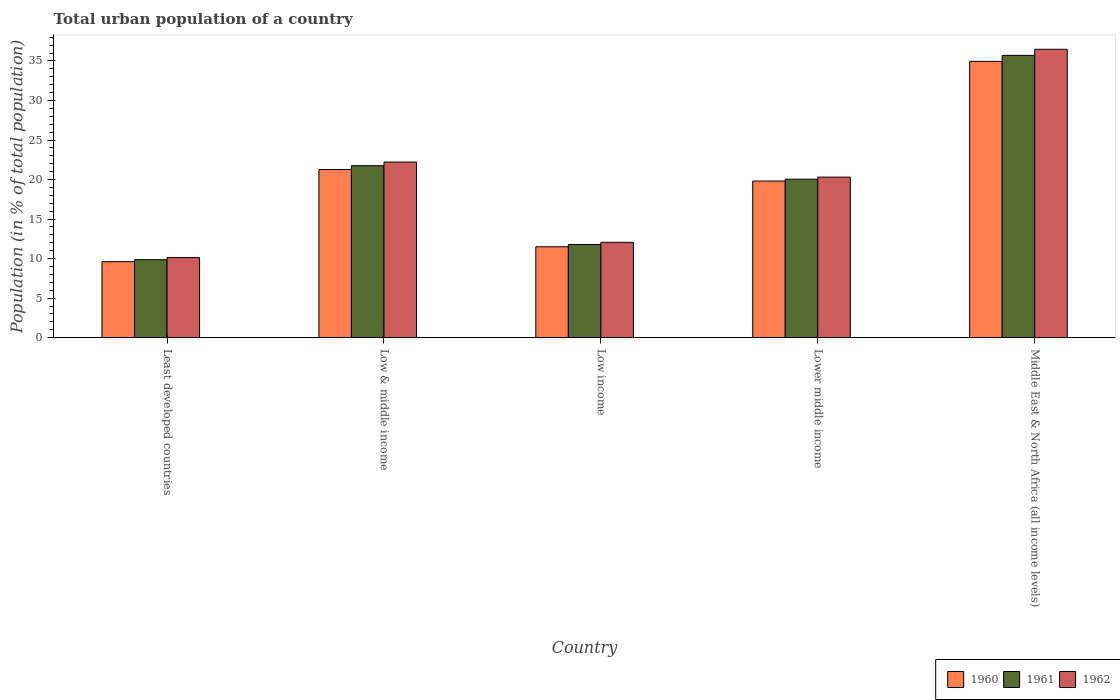What is the label of the 4th group of bars from the left?
Offer a terse response. Lower middle income. In how many cases, is the number of bars for a given country not equal to the number of legend labels?
Your answer should be very brief. 0. What is the urban population in 1962 in Middle East & North Africa (all income levels)?
Offer a very short reply. 36.48. Across all countries, what is the maximum urban population in 1961?
Provide a short and direct response. 35.71. Across all countries, what is the minimum urban population in 1962?
Provide a succinct answer. 10.13. In which country was the urban population in 1961 maximum?
Provide a short and direct response. Middle East & North Africa (all income levels). In which country was the urban population in 1961 minimum?
Offer a terse response. Least developed countries. What is the total urban population in 1962 in the graph?
Your answer should be very brief. 101.19. What is the difference between the urban population in 1962 in Low income and that in Lower middle income?
Your answer should be very brief. -8.25. What is the difference between the urban population in 1961 in Low income and the urban population in 1962 in Least developed countries?
Ensure brevity in your answer.  1.65. What is the average urban population in 1960 per country?
Your answer should be very brief. 19.43. What is the difference between the urban population of/in 1960 and urban population of/in 1961 in Middle East & North Africa (all income levels)?
Offer a very short reply. -0.76. In how many countries, is the urban population in 1961 greater than 5 %?
Keep it short and to the point. 5. What is the ratio of the urban population in 1961 in Low & middle income to that in Middle East & North Africa (all income levels)?
Provide a succinct answer. 0.61. Is the urban population in 1961 in Low & middle income less than that in Middle East & North Africa (all income levels)?
Your response must be concise. Yes. Is the difference between the urban population in 1960 in Low & middle income and Low income greater than the difference between the urban population in 1961 in Low & middle income and Low income?
Make the answer very short. No. What is the difference between the highest and the second highest urban population in 1960?
Your response must be concise. 15.14. What is the difference between the highest and the lowest urban population in 1962?
Ensure brevity in your answer.  26.35. In how many countries, is the urban population in 1961 greater than the average urban population in 1961 taken over all countries?
Provide a short and direct response. 3. Is the sum of the urban population in 1960 in Low income and Middle East & North Africa (all income levels) greater than the maximum urban population in 1962 across all countries?
Keep it short and to the point. Yes. What does the 1st bar from the left in Low & middle income represents?
Provide a succinct answer. 1960. How many countries are there in the graph?
Your response must be concise. 5. Does the graph contain grids?
Keep it short and to the point. No. Where does the legend appear in the graph?
Make the answer very short. Bottom right. How many legend labels are there?
Offer a very short reply. 3. What is the title of the graph?
Offer a terse response. Total urban population of a country. Does "2003" appear as one of the legend labels in the graph?
Offer a terse response. No. What is the label or title of the X-axis?
Offer a terse response. Country. What is the label or title of the Y-axis?
Offer a terse response. Population (in % of total population). What is the Population (in % of total population) of 1960 in Least developed countries?
Provide a succinct answer. 9.62. What is the Population (in % of total population) of 1961 in Least developed countries?
Give a very brief answer. 9.86. What is the Population (in % of total population) of 1962 in Least developed countries?
Your answer should be compact. 10.13. What is the Population (in % of total population) of 1960 in Low & middle income?
Offer a terse response. 21.27. What is the Population (in % of total population) of 1961 in Low & middle income?
Provide a succinct answer. 21.75. What is the Population (in % of total population) of 1962 in Low & middle income?
Keep it short and to the point. 22.22. What is the Population (in % of total population) in 1960 in Low income?
Provide a succinct answer. 11.5. What is the Population (in % of total population) in 1961 in Low income?
Your answer should be compact. 11.78. What is the Population (in % of total population) of 1962 in Low income?
Offer a very short reply. 12.06. What is the Population (in % of total population) of 1960 in Lower middle income?
Your response must be concise. 19.81. What is the Population (in % of total population) in 1961 in Lower middle income?
Give a very brief answer. 20.04. What is the Population (in % of total population) of 1962 in Lower middle income?
Offer a terse response. 20.31. What is the Population (in % of total population) in 1960 in Middle East & North Africa (all income levels)?
Make the answer very short. 34.95. What is the Population (in % of total population) of 1961 in Middle East & North Africa (all income levels)?
Your answer should be very brief. 35.71. What is the Population (in % of total population) of 1962 in Middle East & North Africa (all income levels)?
Offer a very short reply. 36.48. Across all countries, what is the maximum Population (in % of total population) of 1960?
Give a very brief answer. 34.95. Across all countries, what is the maximum Population (in % of total population) in 1961?
Provide a short and direct response. 35.71. Across all countries, what is the maximum Population (in % of total population) of 1962?
Provide a short and direct response. 36.48. Across all countries, what is the minimum Population (in % of total population) in 1960?
Provide a succinct answer. 9.62. Across all countries, what is the minimum Population (in % of total population) of 1961?
Your response must be concise. 9.86. Across all countries, what is the minimum Population (in % of total population) of 1962?
Give a very brief answer. 10.13. What is the total Population (in % of total population) of 1960 in the graph?
Keep it short and to the point. 97.15. What is the total Population (in % of total population) in 1961 in the graph?
Offer a terse response. 99.14. What is the total Population (in % of total population) of 1962 in the graph?
Provide a succinct answer. 101.19. What is the difference between the Population (in % of total population) of 1960 in Least developed countries and that in Low & middle income?
Offer a very short reply. -11.66. What is the difference between the Population (in % of total population) in 1961 in Least developed countries and that in Low & middle income?
Provide a succinct answer. -11.89. What is the difference between the Population (in % of total population) of 1962 in Least developed countries and that in Low & middle income?
Keep it short and to the point. -12.09. What is the difference between the Population (in % of total population) in 1960 in Least developed countries and that in Low income?
Offer a terse response. -1.88. What is the difference between the Population (in % of total population) of 1961 in Least developed countries and that in Low income?
Keep it short and to the point. -1.92. What is the difference between the Population (in % of total population) in 1962 in Least developed countries and that in Low income?
Provide a succinct answer. -1.93. What is the difference between the Population (in % of total population) of 1960 in Least developed countries and that in Lower middle income?
Offer a very short reply. -10.19. What is the difference between the Population (in % of total population) of 1961 in Least developed countries and that in Lower middle income?
Your answer should be compact. -10.18. What is the difference between the Population (in % of total population) in 1962 in Least developed countries and that in Lower middle income?
Offer a terse response. -10.18. What is the difference between the Population (in % of total population) of 1960 in Least developed countries and that in Middle East & North Africa (all income levels)?
Provide a succinct answer. -25.34. What is the difference between the Population (in % of total population) of 1961 in Least developed countries and that in Middle East & North Africa (all income levels)?
Keep it short and to the point. -25.85. What is the difference between the Population (in % of total population) in 1962 in Least developed countries and that in Middle East & North Africa (all income levels)?
Give a very brief answer. -26.35. What is the difference between the Population (in % of total population) in 1960 in Low & middle income and that in Low income?
Your answer should be very brief. 9.77. What is the difference between the Population (in % of total population) of 1961 in Low & middle income and that in Low income?
Your answer should be compact. 9.97. What is the difference between the Population (in % of total population) in 1962 in Low & middle income and that in Low income?
Your response must be concise. 10.16. What is the difference between the Population (in % of total population) of 1960 in Low & middle income and that in Lower middle income?
Offer a very short reply. 1.46. What is the difference between the Population (in % of total population) in 1961 in Low & middle income and that in Lower middle income?
Offer a terse response. 1.71. What is the difference between the Population (in % of total population) of 1962 in Low & middle income and that in Lower middle income?
Keep it short and to the point. 1.91. What is the difference between the Population (in % of total population) in 1960 in Low & middle income and that in Middle East & North Africa (all income levels)?
Offer a terse response. -13.68. What is the difference between the Population (in % of total population) in 1961 in Low & middle income and that in Middle East & North Africa (all income levels)?
Your response must be concise. -13.96. What is the difference between the Population (in % of total population) in 1962 in Low & middle income and that in Middle East & North Africa (all income levels)?
Your response must be concise. -14.26. What is the difference between the Population (in % of total population) in 1960 in Low income and that in Lower middle income?
Make the answer very short. -8.31. What is the difference between the Population (in % of total population) of 1961 in Low income and that in Lower middle income?
Give a very brief answer. -8.26. What is the difference between the Population (in % of total population) of 1962 in Low income and that in Lower middle income?
Keep it short and to the point. -8.25. What is the difference between the Population (in % of total population) of 1960 in Low income and that in Middle East & North Africa (all income levels)?
Ensure brevity in your answer.  -23.45. What is the difference between the Population (in % of total population) of 1961 in Low income and that in Middle East & North Africa (all income levels)?
Provide a succinct answer. -23.93. What is the difference between the Population (in % of total population) of 1962 in Low income and that in Middle East & North Africa (all income levels)?
Provide a short and direct response. -24.42. What is the difference between the Population (in % of total population) in 1960 in Lower middle income and that in Middle East & North Africa (all income levels)?
Your answer should be compact. -15.14. What is the difference between the Population (in % of total population) in 1961 in Lower middle income and that in Middle East & North Africa (all income levels)?
Ensure brevity in your answer.  -15.67. What is the difference between the Population (in % of total population) in 1962 in Lower middle income and that in Middle East & North Africa (all income levels)?
Offer a very short reply. -16.17. What is the difference between the Population (in % of total population) in 1960 in Least developed countries and the Population (in % of total population) in 1961 in Low & middle income?
Your answer should be compact. -12.13. What is the difference between the Population (in % of total population) of 1960 in Least developed countries and the Population (in % of total population) of 1962 in Low & middle income?
Provide a succinct answer. -12.6. What is the difference between the Population (in % of total population) in 1961 in Least developed countries and the Population (in % of total population) in 1962 in Low & middle income?
Your answer should be compact. -12.36. What is the difference between the Population (in % of total population) of 1960 in Least developed countries and the Population (in % of total population) of 1961 in Low income?
Your answer should be very brief. -2.16. What is the difference between the Population (in % of total population) of 1960 in Least developed countries and the Population (in % of total population) of 1962 in Low income?
Your answer should be very brief. -2.44. What is the difference between the Population (in % of total population) in 1961 in Least developed countries and the Population (in % of total population) in 1962 in Low income?
Keep it short and to the point. -2.2. What is the difference between the Population (in % of total population) of 1960 in Least developed countries and the Population (in % of total population) of 1961 in Lower middle income?
Give a very brief answer. -10.43. What is the difference between the Population (in % of total population) in 1960 in Least developed countries and the Population (in % of total population) in 1962 in Lower middle income?
Give a very brief answer. -10.69. What is the difference between the Population (in % of total population) of 1961 in Least developed countries and the Population (in % of total population) of 1962 in Lower middle income?
Provide a short and direct response. -10.45. What is the difference between the Population (in % of total population) of 1960 in Least developed countries and the Population (in % of total population) of 1961 in Middle East & North Africa (all income levels)?
Keep it short and to the point. -26.09. What is the difference between the Population (in % of total population) in 1960 in Least developed countries and the Population (in % of total population) in 1962 in Middle East & North Africa (all income levels)?
Provide a succinct answer. -26.86. What is the difference between the Population (in % of total population) in 1961 in Least developed countries and the Population (in % of total population) in 1962 in Middle East & North Africa (all income levels)?
Your response must be concise. -26.61. What is the difference between the Population (in % of total population) in 1960 in Low & middle income and the Population (in % of total population) in 1961 in Low income?
Offer a very short reply. 9.49. What is the difference between the Population (in % of total population) in 1960 in Low & middle income and the Population (in % of total population) in 1962 in Low income?
Your answer should be very brief. 9.21. What is the difference between the Population (in % of total population) in 1961 in Low & middle income and the Population (in % of total population) in 1962 in Low income?
Your answer should be compact. 9.69. What is the difference between the Population (in % of total population) in 1960 in Low & middle income and the Population (in % of total population) in 1961 in Lower middle income?
Offer a terse response. 1.23. What is the difference between the Population (in % of total population) of 1960 in Low & middle income and the Population (in % of total population) of 1962 in Lower middle income?
Keep it short and to the point. 0.96. What is the difference between the Population (in % of total population) in 1961 in Low & middle income and the Population (in % of total population) in 1962 in Lower middle income?
Your answer should be very brief. 1.44. What is the difference between the Population (in % of total population) in 1960 in Low & middle income and the Population (in % of total population) in 1961 in Middle East & North Africa (all income levels)?
Provide a short and direct response. -14.44. What is the difference between the Population (in % of total population) of 1960 in Low & middle income and the Population (in % of total population) of 1962 in Middle East & North Africa (all income levels)?
Your answer should be compact. -15.2. What is the difference between the Population (in % of total population) in 1961 in Low & middle income and the Population (in % of total population) in 1962 in Middle East & North Africa (all income levels)?
Ensure brevity in your answer.  -14.73. What is the difference between the Population (in % of total population) in 1960 in Low income and the Population (in % of total population) in 1961 in Lower middle income?
Your answer should be very brief. -8.54. What is the difference between the Population (in % of total population) of 1960 in Low income and the Population (in % of total population) of 1962 in Lower middle income?
Provide a succinct answer. -8.81. What is the difference between the Population (in % of total population) in 1961 in Low income and the Population (in % of total population) in 1962 in Lower middle income?
Keep it short and to the point. -8.53. What is the difference between the Population (in % of total population) in 1960 in Low income and the Population (in % of total population) in 1961 in Middle East & North Africa (all income levels)?
Keep it short and to the point. -24.21. What is the difference between the Population (in % of total population) in 1960 in Low income and the Population (in % of total population) in 1962 in Middle East & North Africa (all income levels)?
Your response must be concise. -24.98. What is the difference between the Population (in % of total population) of 1961 in Low income and the Population (in % of total population) of 1962 in Middle East & North Africa (all income levels)?
Give a very brief answer. -24.7. What is the difference between the Population (in % of total population) in 1960 in Lower middle income and the Population (in % of total population) in 1961 in Middle East & North Africa (all income levels)?
Your response must be concise. -15.9. What is the difference between the Population (in % of total population) of 1960 in Lower middle income and the Population (in % of total population) of 1962 in Middle East & North Africa (all income levels)?
Provide a short and direct response. -16.67. What is the difference between the Population (in % of total population) in 1961 in Lower middle income and the Population (in % of total population) in 1962 in Middle East & North Africa (all income levels)?
Make the answer very short. -16.43. What is the average Population (in % of total population) in 1960 per country?
Provide a succinct answer. 19.43. What is the average Population (in % of total population) of 1961 per country?
Ensure brevity in your answer.  19.83. What is the average Population (in % of total population) of 1962 per country?
Your answer should be very brief. 20.24. What is the difference between the Population (in % of total population) of 1960 and Population (in % of total population) of 1961 in Least developed countries?
Make the answer very short. -0.25. What is the difference between the Population (in % of total population) of 1960 and Population (in % of total population) of 1962 in Least developed countries?
Give a very brief answer. -0.51. What is the difference between the Population (in % of total population) in 1961 and Population (in % of total population) in 1962 in Least developed countries?
Your response must be concise. -0.27. What is the difference between the Population (in % of total population) in 1960 and Population (in % of total population) in 1961 in Low & middle income?
Offer a very short reply. -0.48. What is the difference between the Population (in % of total population) of 1960 and Population (in % of total population) of 1962 in Low & middle income?
Give a very brief answer. -0.95. What is the difference between the Population (in % of total population) in 1961 and Population (in % of total population) in 1962 in Low & middle income?
Your response must be concise. -0.47. What is the difference between the Population (in % of total population) of 1960 and Population (in % of total population) of 1961 in Low income?
Your answer should be very brief. -0.28. What is the difference between the Population (in % of total population) in 1960 and Population (in % of total population) in 1962 in Low income?
Provide a short and direct response. -0.56. What is the difference between the Population (in % of total population) of 1961 and Population (in % of total population) of 1962 in Low income?
Provide a short and direct response. -0.28. What is the difference between the Population (in % of total population) in 1960 and Population (in % of total population) in 1961 in Lower middle income?
Offer a very short reply. -0.23. What is the difference between the Population (in % of total population) in 1960 and Population (in % of total population) in 1962 in Lower middle income?
Your answer should be very brief. -0.5. What is the difference between the Population (in % of total population) in 1961 and Population (in % of total population) in 1962 in Lower middle income?
Make the answer very short. -0.27. What is the difference between the Population (in % of total population) of 1960 and Population (in % of total population) of 1961 in Middle East & North Africa (all income levels)?
Provide a succinct answer. -0.76. What is the difference between the Population (in % of total population) of 1960 and Population (in % of total population) of 1962 in Middle East & North Africa (all income levels)?
Your answer should be very brief. -1.53. What is the difference between the Population (in % of total population) in 1961 and Population (in % of total population) in 1962 in Middle East & North Africa (all income levels)?
Your response must be concise. -0.77. What is the ratio of the Population (in % of total population) in 1960 in Least developed countries to that in Low & middle income?
Ensure brevity in your answer.  0.45. What is the ratio of the Population (in % of total population) of 1961 in Least developed countries to that in Low & middle income?
Provide a short and direct response. 0.45. What is the ratio of the Population (in % of total population) in 1962 in Least developed countries to that in Low & middle income?
Offer a terse response. 0.46. What is the ratio of the Population (in % of total population) in 1960 in Least developed countries to that in Low income?
Your answer should be compact. 0.84. What is the ratio of the Population (in % of total population) in 1961 in Least developed countries to that in Low income?
Offer a terse response. 0.84. What is the ratio of the Population (in % of total population) in 1962 in Least developed countries to that in Low income?
Ensure brevity in your answer.  0.84. What is the ratio of the Population (in % of total population) of 1960 in Least developed countries to that in Lower middle income?
Provide a succinct answer. 0.49. What is the ratio of the Population (in % of total population) in 1961 in Least developed countries to that in Lower middle income?
Give a very brief answer. 0.49. What is the ratio of the Population (in % of total population) of 1962 in Least developed countries to that in Lower middle income?
Keep it short and to the point. 0.5. What is the ratio of the Population (in % of total population) in 1960 in Least developed countries to that in Middle East & North Africa (all income levels)?
Provide a succinct answer. 0.28. What is the ratio of the Population (in % of total population) of 1961 in Least developed countries to that in Middle East & North Africa (all income levels)?
Your response must be concise. 0.28. What is the ratio of the Population (in % of total population) in 1962 in Least developed countries to that in Middle East & North Africa (all income levels)?
Give a very brief answer. 0.28. What is the ratio of the Population (in % of total population) of 1960 in Low & middle income to that in Low income?
Offer a very short reply. 1.85. What is the ratio of the Population (in % of total population) of 1961 in Low & middle income to that in Low income?
Your response must be concise. 1.85. What is the ratio of the Population (in % of total population) of 1962 in Low & middle income to that in Low income?
Your answer should be very brief. 1.84. What is the ratio of the Population (in % of total population) in 1960 in Low & middle income to that in Lower middle income?
Keep it short and to the point. 1.07. What is the ratio of the Population (in % of total population) in 1961 in Low & middle income to that in Lower middle income?
Your answer should be very brief. 1.09. What is the ratio of the Population (in % of total population) in 1962 in Low & middle income to that in Lower middle income?
Offer a terse response. 1.09. What is the ratio of the Population (in % of total population) in 1960 in Low & middle income to that in Middle East & North Africa (all income levels)?
Your answer should be compact. 0.61. What is the ratio of the Population (in % of total population) in 1961 in Low & middle income to that in Middle East & North Africa (all income levels)?
Your answer should be compact. 0.61. What is the ratio of the Population (in % of total population) in 1962 in Low & middle income to that in Middle East & North Africa (all income levels)?
Offer a very short reply. 0.61. What is the ratio of the Population (in % of total population) of 1960 in Low income to that in Lower middle income?
Make the answer very short. 0.58. What is the ratio of the Population (in % of total population) of 1961 in Low income to that in Lower middle income?
Provide a succinct answer. 0.59. What is the ratio of the Population (in % of total population) of 1962 in Low income to that in Lower middle income?
Keep it short and to the point. 0.59. What is the ratio of the Population (in % of total population) in 1960 in Low income to that in Middle East & North Africa (all income levels)?
Your answer should be very brief. 0.33. What is the ratio of the Population (in % of total population) of 1961 in Low income to that in Middle East & North Africa (all income levels)?
Your answer should be compact. 0.33. What is the ratio of the Population (in % of total population) in 1962 in Low income to that in Middle East & North Africa (all income levels)?
Offer a terse response. 0.33. What is the ratio of the Population (in % of total population) of 1960 in Lower middle income to that in Middle East & North Africa (all income levels)?
Offer a very short reply. 0.57. What is the ratio of the Population (in % of total population) of 1961 in Lower middle income to that in Middle East & North Africa (all income levels)?
Offer a very short reply. 0.56. What is the ratio of the Population (in % of total population) of 1962 in Lower middle income to that in Middle East & North Africa (all income levels)?
Provide a short and direct response. 0.56. What is the difference between the highest and the second highest Population (in % of total population) of 1960?
Provide a short and direct response. 13.68. What is the difference between the highest and the second highest Population (in % of total population) in 1961?
Provide a succinct answer. 13.96. What is the difference between the highest and the second highest Population (in % of total population) of 1962?
Offer a terse response. 14.26. What is the difference between the highest and the lowest Population (in % of total population) of 1960?
Provide a short and direct response. 25.34. What is the difference between the highest and the lowest Population (in % of total population) in 1961?
Make the answer very short. 25.85. What is the difference between the highest and the lowest Population (in % of total population) in 1962?
Ensure brevity in your answer.  26.35. 